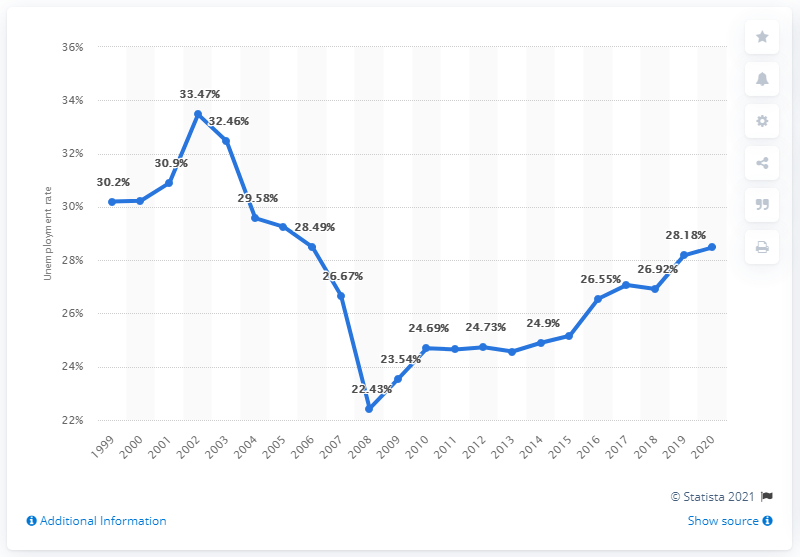Identify some key points in this picture. In 2020, the unemployment rate in South Africa was 28.48%. 